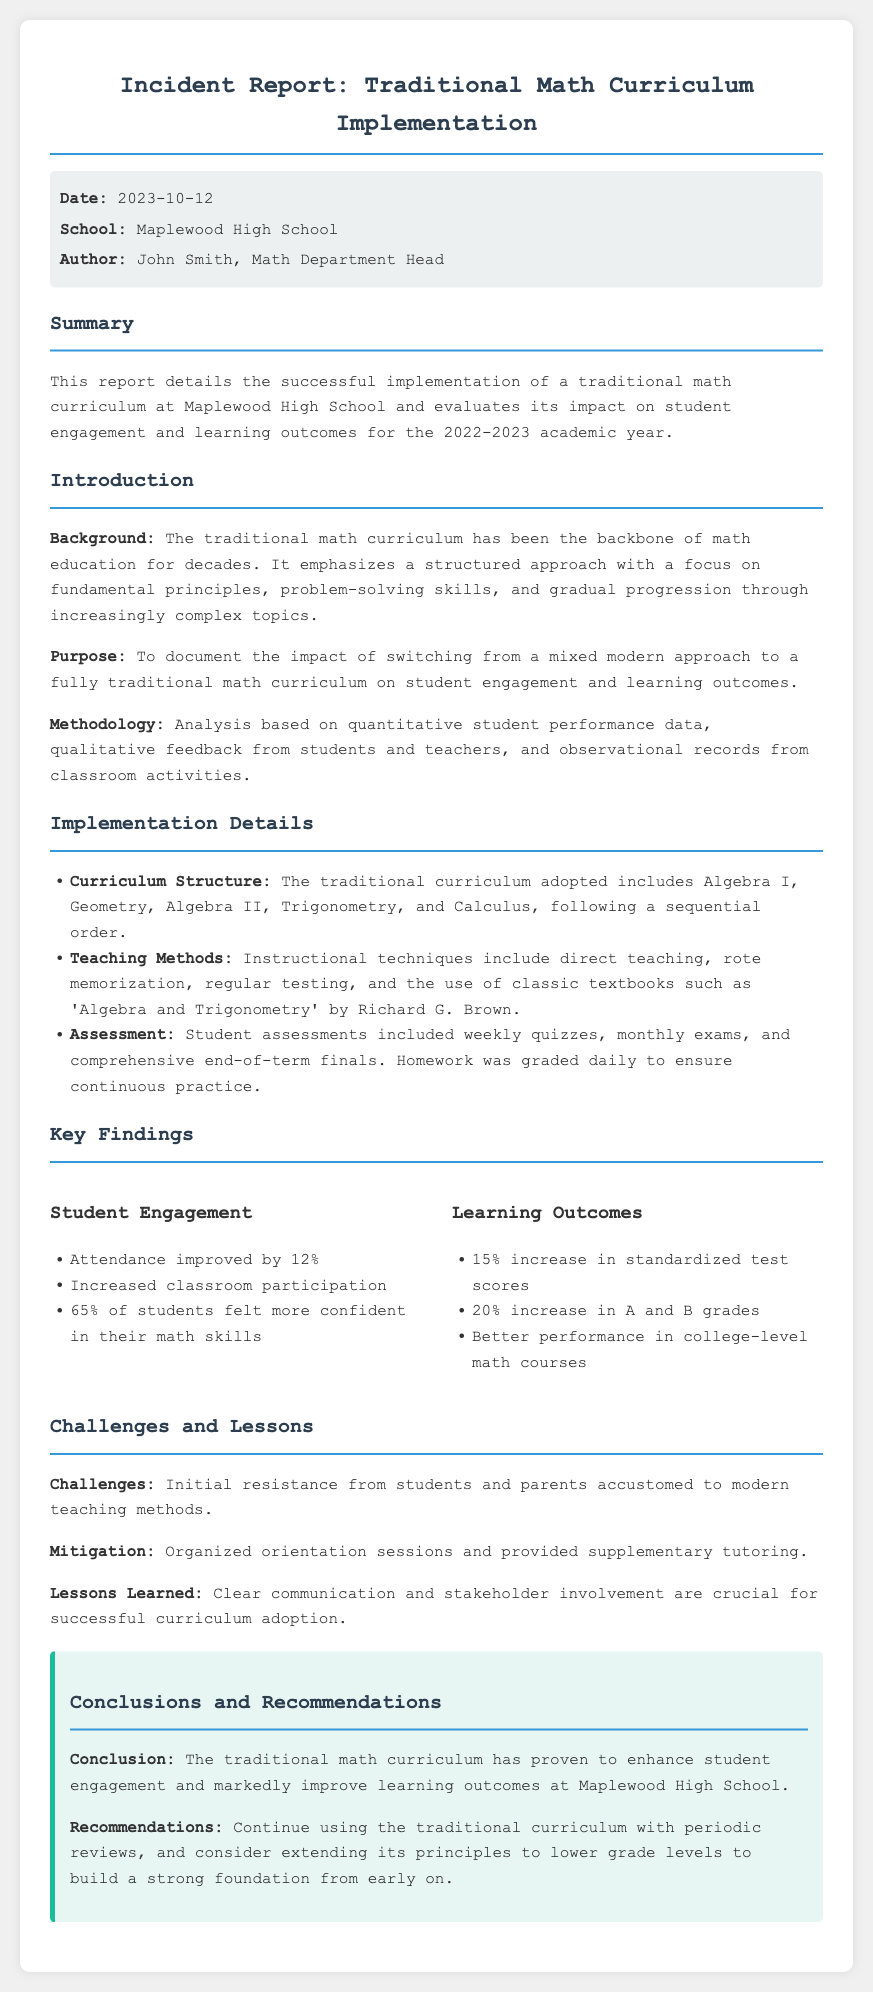What is the date of the incident report? The date of the incident report is mentioned in the meta section as October 12, 2023.
Answer: October 12, 2023 Who authored the report? The report is authored by John Smith, who is the Math Department Head.
Answer: John Smith What percentage of students felt more confident in their math skills? The report indicates that 65% of students felt more confident in their math skills.
Answer: 65% What was the increase in attendance? The report states that attendance improved by 12%.
Answer: 12% What is the recommended future action for the curriculum? The report recommends continuing the use of the traditional curriculum with periodic reviews.
Answer: Continue using the traditional curriculum with periodic reviews What subject areas does the curriculum cover? The implemented curriculum includes Algebra I, Geometry, Algebra II, Trigonometry, and Calculus.
Answer: Algebra I, Geometry, Algebra II, Trigonometry, Calculus What challenge was faced during the implementation? The report notes initial resistance from students and parents accustomed to modern teaching methods.
Answer: Initial resistance from students and parents What tools were used for assessments? The assessments included weekly quizzes, monthly exams, and comprehensive end-of-term finals.
Answer: Weekly quizzes, monthly exams, and comprehensive end-of-term finals What effect did the curriculum have on standardized test scores? The report mentions a 15% increase in standardized test scores as a finding.
Answer: 15% increase 